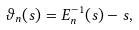Convert formula to latex. <formula><loc_0><loc_0><loc_500><loc_500>\vartheta _ { n } ( s ) = E _ { n } ^ { - 1 } ( s ) - s ,</formula> 